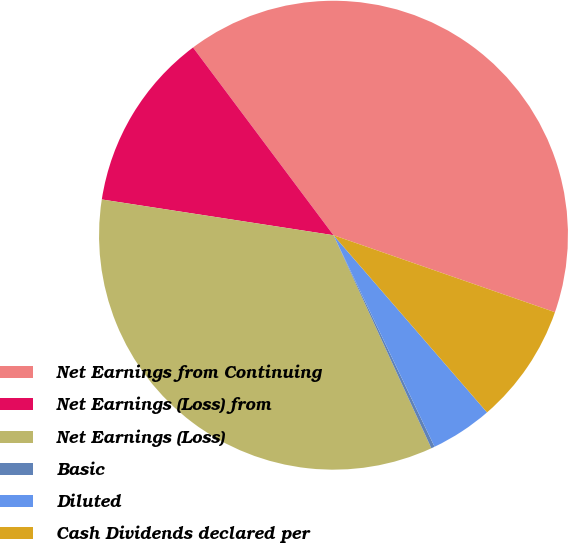Convert chart to OTSL. <chart><loc_0><loc_0><loc_500><loc_500><pie_chart><fcel>Net Earnings from Continuing<fcel>Net Earnings (Loss) from<fcel>Net Earnings (Loss)<fcel>Basic<fcel>Diluted<fcel>Cash Dividends declared per<nl><fcel>40.55%<fcel>12.34%<fcel>34.29%<fcel>0.24%<fcel>4.27%<fcel>8.31%<nl></chart> 